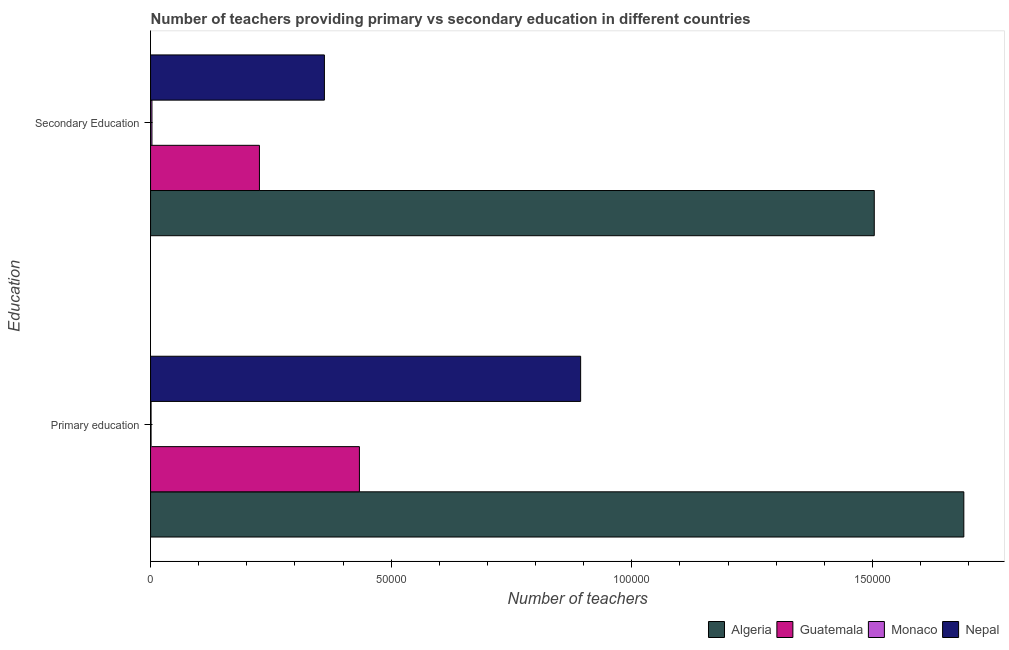How many different coloured bars are there?
Your answer should be very brief. 4. Are the number of bars per tick equal to the number of legend labels?
Keep it short and to the point. Yes. Are the number of bars on each tick of the Y-axis equal?
Offer a terse response. Yes. How many bars are there on the 1st tick from the top?
Offer a very short reply. 4. What is the label of the 2nd group of bars from the top?
Provide a succinct answer. Primary education. What is the number of secondary teachers in Guatemala?
Offer a terse response. 2.26e+04. Across all countries, what is the maximum number of secondary teachers?
Offer a very short reply. 1.50e+05. Across all countries, what is the minimum number of primary teachers?
Ensure brevity in your answer.  102. In which country was the number of primary teachers maximum?
Your answer should be very brief. Algeria. In which country was the number of secondary teachers minimum?
Offer a very short reply. Monaco. What is the total number of secondary teachers in the graph?
Make the answer very short. 2.09e+05. What is the difference between the number of primary teachers in Algeria and that in Nepal?
Provide a succinct answer. 7.96e+04. What is the difference between the number of secondary teachers in Monaco and the number of primary teachers in Nepal?
Your answer should be compact. -8.91e+04. What is the average number of primary teachers per country?
Provide a succinct answer. 7.55e+04. What is the difference between the number of primary teachers and number of secondary teachers in Monaco?
Your response must be concise. -185. What is the ratio of the number of secondary teachers in Monaco to that in Guatemala?
Ensure brevity in your answer.  0.01. Is the number of secondary teachers in Nepal less than that in Algeria?
Your answer should be compact. Yes. What does the 1st bar from the top in Secondary Education represents?
Your answer should be compact. Nepal. What does the 3rd bar from the bottom in Primary education represents?
Make the answer very short. Monaco. Are all the bars in the graph horizontal?
Ensure brevity in your answer.  Yes. What is the difference between two consecutive major ticks on the X-axis?
Your response must be concise. 5.00e+04. Are the values on the major ticks of X-axis written in scientific E-notation?
Provide a succinct answer. No. Does the graph contain any zero values?
Your answer should be very brief. No. Does the graph contain grids?
Make the answer very short. No. What is the title of the graph?
Your response must be concise. Number of teachers providing primary vs secondary education in different countries. What is the label or title of the X-axis?
Provide a succinct answer. Number of teachers. What is the label or title of the Y-axis?
Make the answer very short. Education. What is the Number of teachers in Algeria in Primary education?
Provide a succinct answer. 1.69e+05. What is the Number of teachers of Guatemala in Primary education?
Give a very brief answer. 4.34e+04. What is the Number of teachers in Monaco in Primary education?
Your answer should be compact. 102. What is the Number of teachers in Nepal in Primary education?
Offer a terse response. 8.94e+04. What is the Number of teachers of Algeria in Secondary Education?
Your answer should be compact. 1.50e+05. What is the Number of teachers of Guatemala in Secondary Education?
Give a very brief answer. 2.26e+04. What is the Number of teachers in Monaco in Secondary Education?
Give a very brief answer. 287. What is the Number of teachers in Nepal in Secondary Education?
Your answer should be compact. 3.61e+04. Across all Education, what is the maximum Number of teachers in Algeria?
Provide a succinct answer. 1.69e+05. Across all Education, what is the maximum Number of teachers in Guatemala?
Ensure brevity in your answer.  4.34e+04. Across all Education, what is the maximum Number of teachers in Monaco?
Make the answer very short. 287. Across all Education, what is the maximum Number of teachers of Nepal?
Your answer should be very brief. 8.94e+04. Across all Education, what is the minimum Number of teachers of Algeria?
Keep it short and to the point. 1.50e+05. Across all Education, what is the minimum Number of teachers in Guatemala?
Your answer should be compact. 2.26e+04. Across all Education, what is the minimum Number of teachers in Monaco?
Give a very brief answer. 102. Across all Education, what is the minimum Number of teachers in Nepal?
Provide a short and direct response. 3.61e+04. What is the total Number of teachers in Algeria in the graph?
Offer a very short reply. 3.19e+05. What is the total Number of teachers of Guatemala in the graph?
Give a very brief answer. 6.60e+04. What is the total Number of teachers in Monaco in the graph?
Your response must be concise. 389. What is the total Number of teachers in Nepal in the graph?
Offer a very short reply. 1.26e+05. What is the difference between the Number of teachers of Algeria in Primary education and that in Secondary Education?
Offer a terse response. 1.86e+04. What is the difference between the Number of teachers in Guatemala in Primary education and that in Secondary Education?
Your response must be concise. 2.08e+04. What is the difference between the Number of teachers in Monaco in Primary education and that in Secondary Education?
Give a very brief answer. -185. What is the difference between the Number of teachers of Nepal in Primary education and that in Secondary Education?
Provide a short and direct response. 5.33e+04. What is the difference between the Number of teachers of Algeria in Primary education and the Number of teachers of Guatemala in Secondary Education?
Your answer should be very brief. 1.46e+05. What is the difference between the Number of teachers in Algeria in Primary education and the Number of teachers in Monaco in Secondary Education?
Give a very brief answer. 1.69e+05. What is the difference between the Number of teachers in Algeria in Primary education and the Number of teachers in Nepal in Secondary Education?
Provide a short and direct response. 1.33e+05. What is the difference between the Number of teachers in Guatemala in Primary education and the Number of teachers in Monaco in Secondary Education?
Give a very brief answer. 4.31e+04. What is the difference between the Number of teachers in Guatemala in Primary education and the Number of teachers in Nepal in Secondary Education?
Give a very brief answer. 7276. What is the difference between the Number of teachers of Monaco in Primary education and the Number of teachers of Nepal in Secondary Education?
Make the answer very short. -3.60e+04. What is the average Number of teachers of Algeria per Education?
Your response must be concise. 1.60e+05. What is the average Number of teachers of Guatemala per Education?
Provide a short and direct response. 3.30e+04. What is the average Number of teachers in Monaco per Education?
Ensure brevity in your answer.  194.5. What is the average Number of teachers of Nepal per Education?
Offer a very short reply. 6.28e+04. What is the difference between the Number of teachers of Algeria and Number of teachers of Guatemala in Primary education?
Make the answer very short. 1.26e+05. What is the difference between the Number of teachers of Algeria and Number of teachers of Monaco in Primary education?
Your response must be concise. 1.69e+05. What is the difference between the Number of teachers in Algeria and Number of teachers in Nepal in Primary education?
Make the answer very short. 7.96e+04. What is the difference between the Number of teachers in Guatemala and Number of teachers in Monaco in Primary education?
Your answer should be compact. 4.33e+04. What is the difference between the Number of teachers in Guatemala and Number of teachers in Nepal in Primary education?
Give a very brief answer. -4.60e+04. What is the difference between the Number of teachers in Monaco and Number of teachers in Nepal in Primary education?
Ensure brevity in your answer.  -8.93e+04. What is the difference between the Number of teachers in Algeria and Number of teachers in Guatemala in Secondary Education?
Provide a short and direct response. 1.28e+05. What is the difference between the Number of teachers of Algeria and Number of teachers of Monaco in Secondary Education?
Give a very brief answer. 1.50e+05. What is the difference between the Number of teachers in Algeria and Number of teachers in Nepal in Secondary Education?
Your answer should be very brief. 1.14e+05. What is the difference between the Number of teachers in Guatemala and Number of teachers in Monaco in Secondary Education?
Your response must be concise. 2.23e+04. What is the difference between the Number of teachers in Guatemala and Number of teachers in Nepal in Secondary Education?
Make the answer very short. -1.35e+04. What is the difference between the Number of teachers in Monaco and Number of teachers in Nepal in Secondary Education?
Provide a succinct answer. -3.58e+04. What is the ratio of the Number of teachers in Algeria in Primary education to that in Secondary Education?
Your answer should be compact. 1.12. What is the ratio of the Number of teachers in Guatemala in Primary education to that in Secondary Education?
Your answer should be very brief. 1.92. What is the ratio of the Number of teachers of Monaco in Primary education to that in Secondary Education?
Ensure brevity in your answer.  0.36. What is the ratio of the Number of teachers of Nepal in Primary education to that in Secondary Education?
Make the answer very short. 2.47. What is the difference between the highest and the second highest Number of teachers in Algeria?
Offer a terse response. 1.86e+04. What is the difference between the highest and the second highest Number of teachers in Guatemala?
Your answer should be very brief. 2.08e+04. What is the difference between the highest and the second highest Number of teachers of Monaco?
Your answer should be very brief. 185. What is the difference between the highest and the second highest Number of teachers of Nepal?
Ensure brevity in your answer.  5.33e+04. What is the difference between the highest and the lowest Number of teachers in Algeria?
Ensure brevity in your answer.  1.86e+04. What is the difference between the highest and the lowest Number of teachers of Guatemala?
Your answer should be very brief. 2.08e+04. What is the difference between the highest and the lowest Number of teachers in Monaco?
Provide a short and direct response. 185. What is the difference between the highest and the lowest Number of teachers of Nepal?
Your response must be concise. 5.33e+04. 